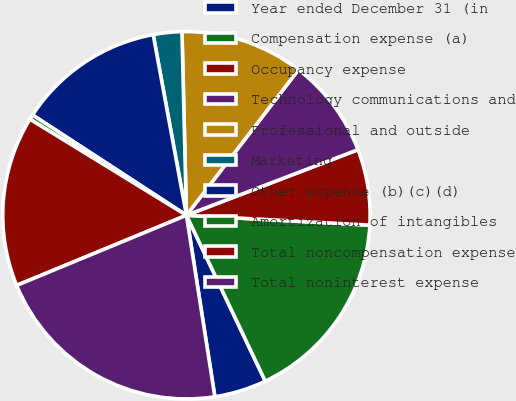<chart> <loc_0><loc_0><loc_500><loc_500><pie_chart><fcel>Year ended December 31 (in<fcel>Compensation expense (a)<fcel>Occupancy expense<fcel>Technology communications and<fcel>Professional and outside<fcel>Marketing<fcel>Other expense (b)(c)(d)<fcel>Amortization of intangibles<fcel>Total noncompensation expense<fcel>Total noninterest expense<nl><fcel>4.59%<fcel>17.08%<fcel>6.67%<fcel>8.75%<fcel>10.83%<fcel>2.51%<fcel>12.91%<fcel>0.43%<fcel>15.0%<fcel>21.24%<nl></chart> 